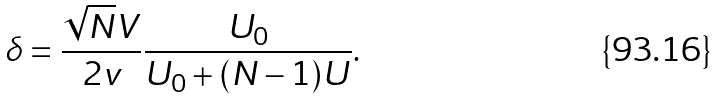<formula> <loc_0><loc_0><loc_500><loc_500>\delta = \frac { \sqrt { N } V } { 2 v } \frac { U _ { 0 } } { U _ { 0 } + ( N - 1 ) U } .</formula> 